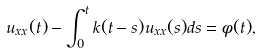Convert formula to latex. <formula><loc_0><loc_0><loc_500><loc_500>u _ { x x } ( t ) - \int _ { 0 } ^ { t } k ( t - s ) u _ { x x } ( s ) d s = \phi ( t ) ,</formula> 